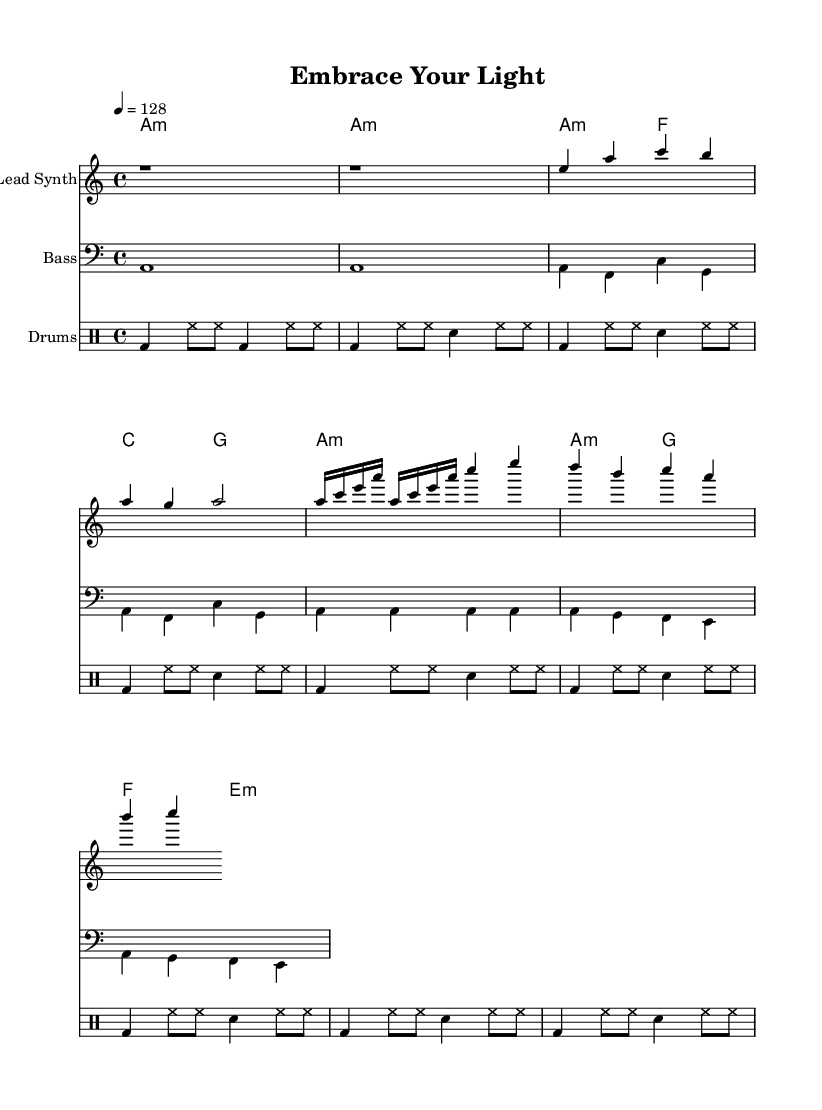What is the key signature of this music? The key signature is A minor, indicated by the absence of sharps or flats in the music. A minor is a relative minor scale to C major, which also has no sharps or flats, denoted by the key signature at the beginning of the score.
Answer: A minor What is the time signature of the piece? The time signature is 4/4, which means there are four beats in each measure and the quarter note receives one beat. This is indicated in the score next to the key signature at the start.
Answer: 4/4 What is the tempo marking for this piece? The tempo marking is 128 beats per minute, denoted by the instruction "4 = 128". This indicates that there are 128 quarter note beats in one minute, providing a moderate pace suitable for dance music.
Answer: 128 How many measures are in the verse section? The verse section consists of 4 measures: the first measure contains notes e, a, c, b, the second a, g, a, followed by two repeated measures that are part of the build-up. To determine this, we can count the number of measures containing distinct musical phrases in the verse section.
Answer: 4 What is the first chord played in the intro? The first chord played in the intro is A minor, indicated by the chord name "a:m" at the beginning of the score. This chord is confirmed by the harmonic structure shown in the chord part throughout the introduction section of the music.
Answer: A minor What is the primary rhythmic pattern used in the drums? The primary rhythmic pattern in the drums features a kick drum on the downbeats and hi-hat hits in between, reflected in the drum part notation. Essentially, the entrance of the bass drum on beats 1 and 3 and the consistent hi-hat pattern creates a strong dance rhythm throughout the piece.
Answer: Kick and hi-hat 